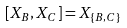Convert formula to latex. <formula><loc_0><loc_0><loc_500><loc_500>[ X _ { B } , X _ { C } ] = X _ { \{ B , C \} }</formula> 